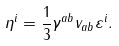<formula> <loc_0><loc_0><loc_500><loc_500>\eta ^ { i } = \frac { 1 } { 3 } \gamma ^ { a b } v _ { a b } \varepsilon ^ { i } .</formula> 